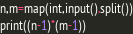Convert code to text. <code><loc_0><loc_0><loc_500><loc_500><_Python_>n,m=map(int,input().split())
print((n-1)*(m-1))</code> 